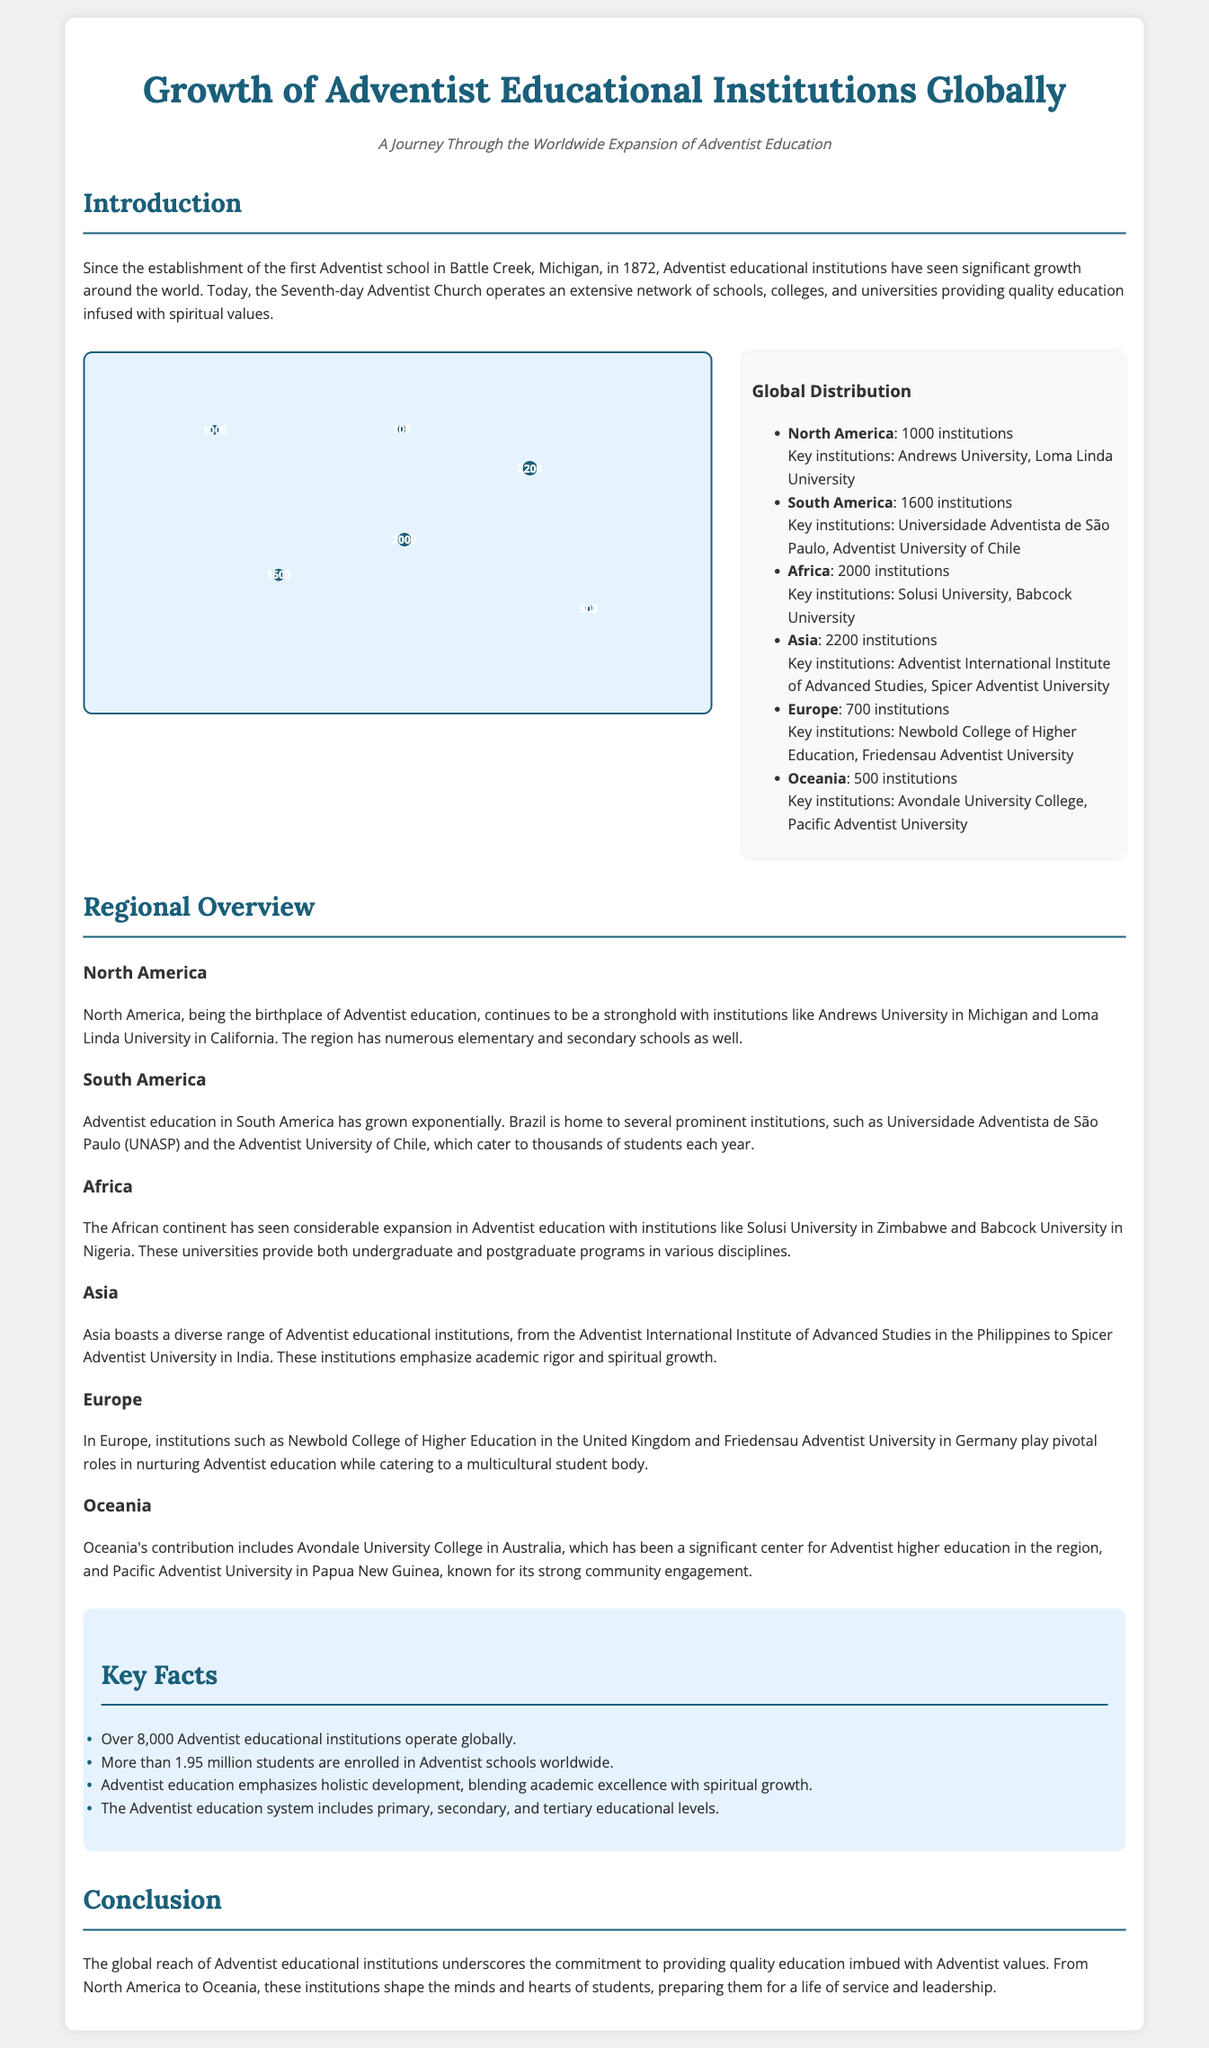What year was the first Adventist school established? The document states that the first Adventist school was established in 1872.
Answer: 1872 How many Adventist educational institutions operate globally? The document mentions that over 8,000 Adventist educational institutions are in operation around the world.
Answer: 8,000 Which region has the highest number of Adventist institutions? According to the infographic data, Asia has 2,200 institutions, the highest among all regions listed.
Answer: Asia Name one highlighted institution in South America. The document lists Universidade Adventista de São Paulo as one highlighted institution in South America.
Answer: Universidade Adventista de São Paulo How many students are enrolled in Adventist schools worldwide? The document states that there are more than 1.95 million students enrolled in Adventist schools globally.
Answer: 1.95 million What is a key focus of Adventist education? The document emphasizes that Adventist education blends academic excellence with spiritual growth.
Answer: Spiritual growth Which institution is noted as a significant center for Adventist higher education in Oceania? The document indicates that Avondale University College is a significant center for Adventist higher education in Oceania.
Answer: Avondale University College What narrative does the subtitle of this document convey? The subtitle mentions a journey through the worldwide expansion of Adventist education, suggesting a historical perspective on growth.
Answer: Worldwide expansion Which region features Newbold College of Higher Education? The document indicates that Newbold College of Higher Education is located in Europe.
Answer: Europe 